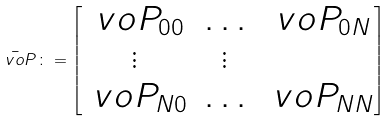<formula> <loc_0><loc_0><loc_500><loc_500>\bar { \ v o { P } } \colon = \begin{bmatrix} \ v o { P } _ { 0 0 } & \hdots & \ v o { P } _ { 0 N } \\ \vdots & \vdots \\ \ v o { P } _ { N 0 } & \hdots & \ v o { P } _ { N N } \end{bmatrix}</formula> 